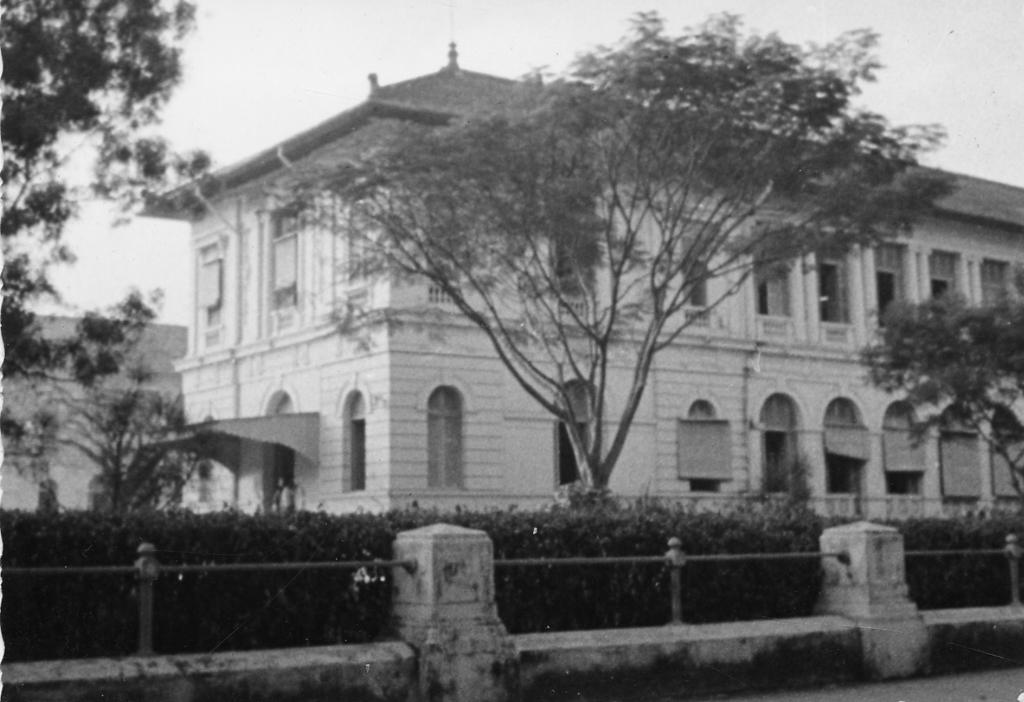What is the color scheme of the image? The image is black and white. What type of structure can be seen in the image? There is a building in the image. What type of vegetation is present in the image? There are trees and shrubs in the image. What might be used to separate or protect an area in the image? There is a barrier in the image. What part of the natural environment is visible in the image? The sky is visible in the image. How much interest does the building in the image generate? The image does not provide any information about the financial aspects or potential interest generated by the building. 